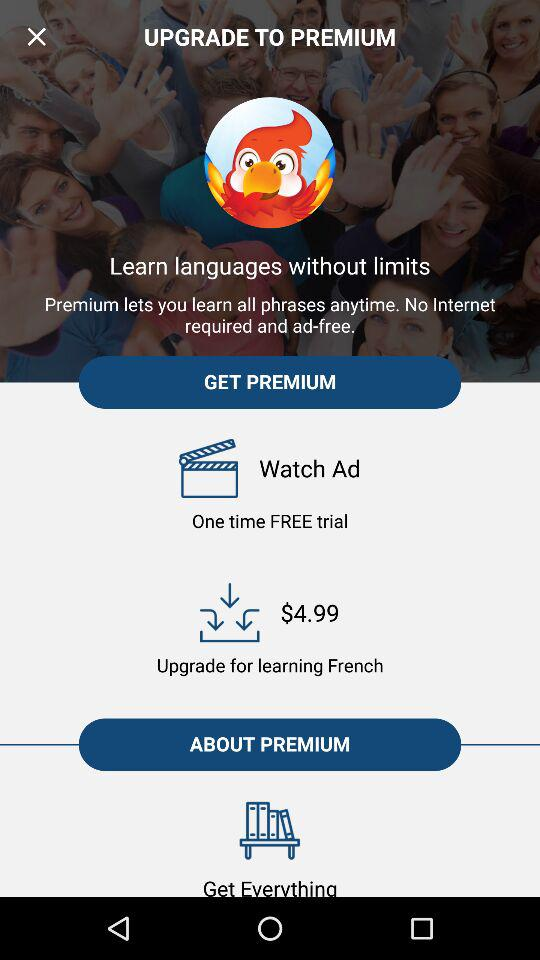What's the price of an upgrade for learning French? The price of an upgrade for learning French is $4.99. 